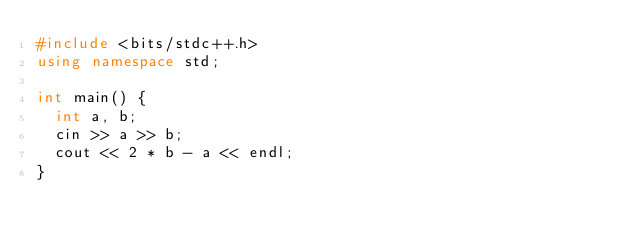<code> <loc_0><loc_0><loc_500><loc_500><_C++_>#include <bits/stdc++.h>
using namespace std;

int main() {
  int a, b;
  cin >> a >> b;
  cout << 2 * b - a << endl;
}</code> 